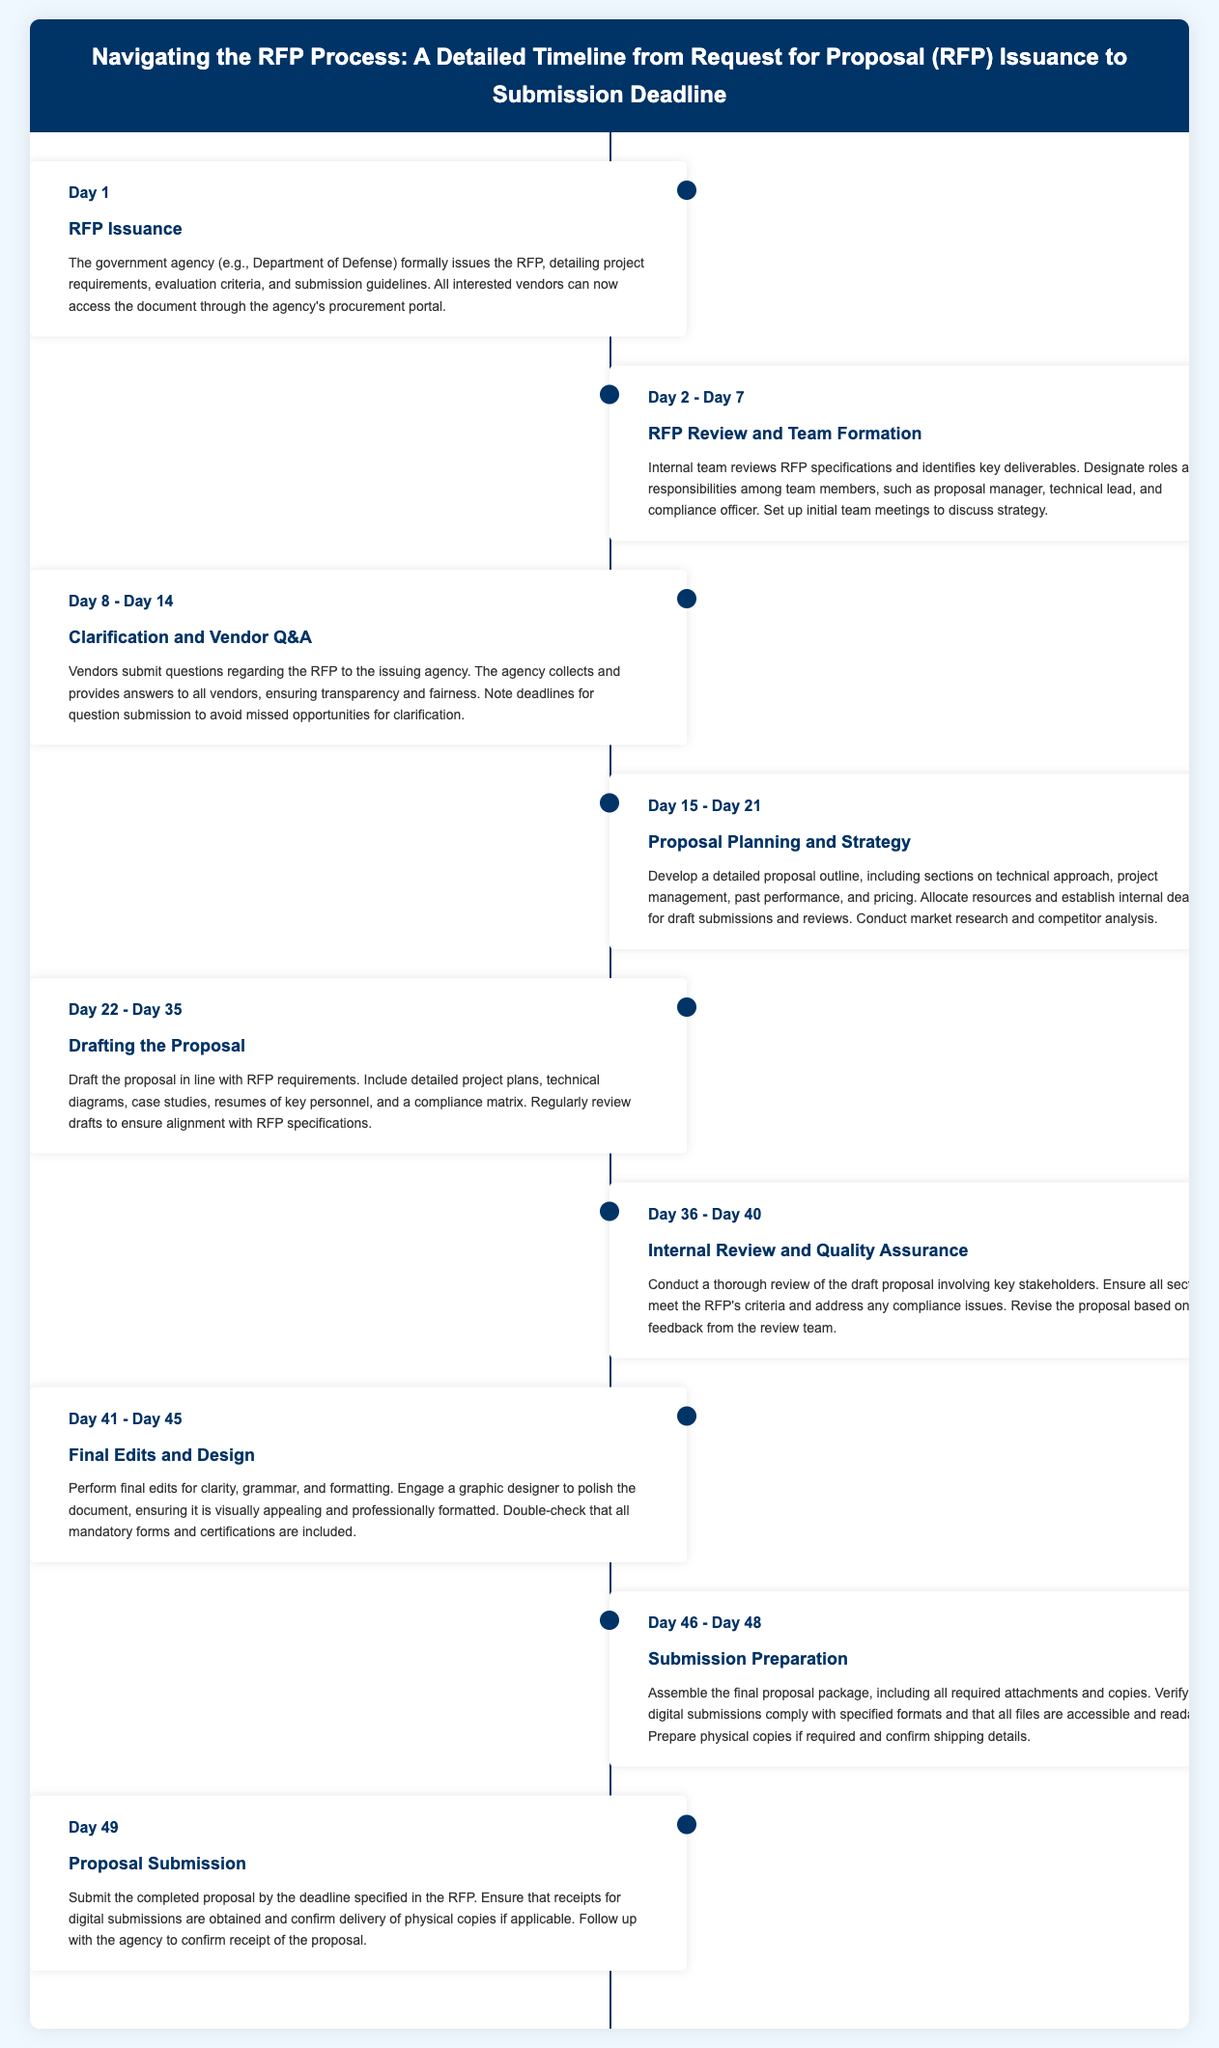What is the first step in the RFP process? The first step is when the government agency formally issues the RFP detailing project requirements.
Answer: RFP Issuance What is the date range for Proposal Planning and Strategy? The date range for Proposal Planning and Strategy is from Day 15 to Day 21.
Answer: Day 15 - Day 21 How many days are allocated for drafting the proposal? The timeline indicates that drafting the proposal takes from Day 22 to Day 35, which is a total of 14 days.
Answer: 14 days What role is designated during the RFP Review and Team Formation? The roles designated include proposal manager, technical lead, and compliance officer among team members.
Answer: proposal manager, technical lead, compliance officer What is done during the Internal Review and Quality Assurance phase? During this phase, a thorough review of the draft proposal is conducted involving key stakeholders to meet the RFP's criteria.
Answer: Review of the draft proposal On which day is the Proposal Submission scheduled? The submission of the completed proposal is scheduled for Day 49.
Answer: Day 49 How long is the Submission Preparation phase? The Submission Preparation phase lasts from Day 46 to Day 48, which is 3 days.
Answer: 3 days What type of document is produced at the end of the RFP process? At the end of the process, a completed proposal is submitted.
Answer: completed proposal 